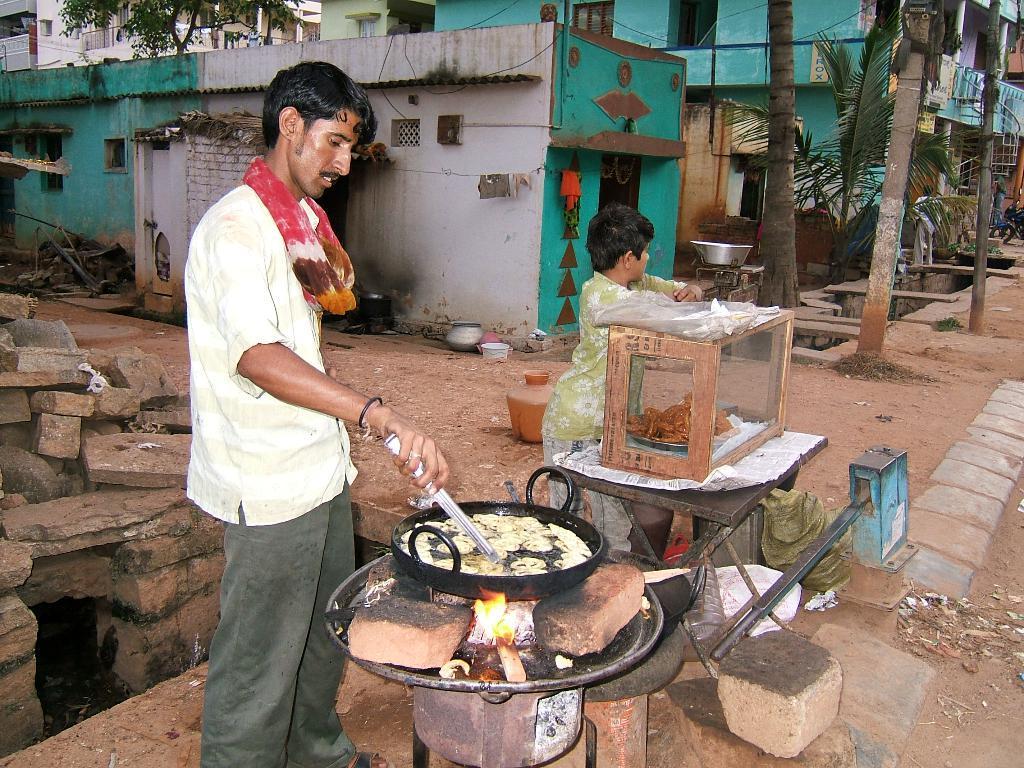How would you summarize this image in a sentence or two? In this picture there is a man, standing in the front and making sweets in black pan. Beside there is a boy standing at the glass table. Behind there are small houses and trees. In the background we can see some stones. 